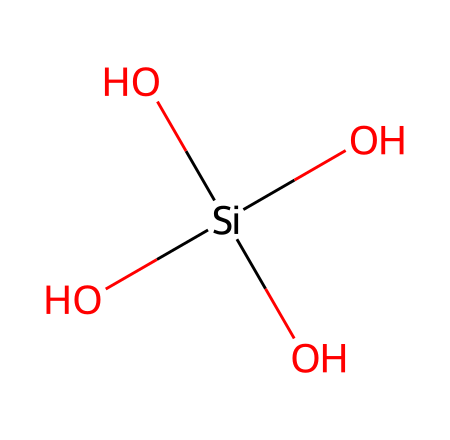What is the central atom in this structure? The central atom is silicon, as it is the only atom depicted in the structure and is bonded to multiple hydroxyl groups.
Answer: silicon How many hydroxyl groups are attached to the central atom? There are four hydroxyl groups (-OH) attached to the silicon atom as evidenced by the four surrounding oxygen atoms each associated with a hydrogen.
Answer: four What type of bonding is primarily present in this structure? This chemical features covalent bonding between silicon and oxygen atoms, allowing for the stability of the silicon compound.
Answer: covalent What functional group is present in this chemical structure? The presence of multiple hydroxyl groups indicates that this chemical contains alcohol functional groups.
Answer: alcohol Explain the role of silicon in optical fiber cores. Silicon, being a semiconductor or glass-forming material, provides the necessary refractive index and structural integrity for light transmission in optical fibers.
Answer: light transmission What type of interactions will this chemical structure likely favor due to its functional groups? The hydroxyl groups can participate in hydrogen bonding; therefore, this structure will likely favor polar interactions.
Answer: hydrogen bonding Can this compound be classified as inorganic or organic? Given the presence of silicon and hydroxyl groups, it can be classified as an inorganic compound, specifically a silicate structure.
Answer: inorganic 